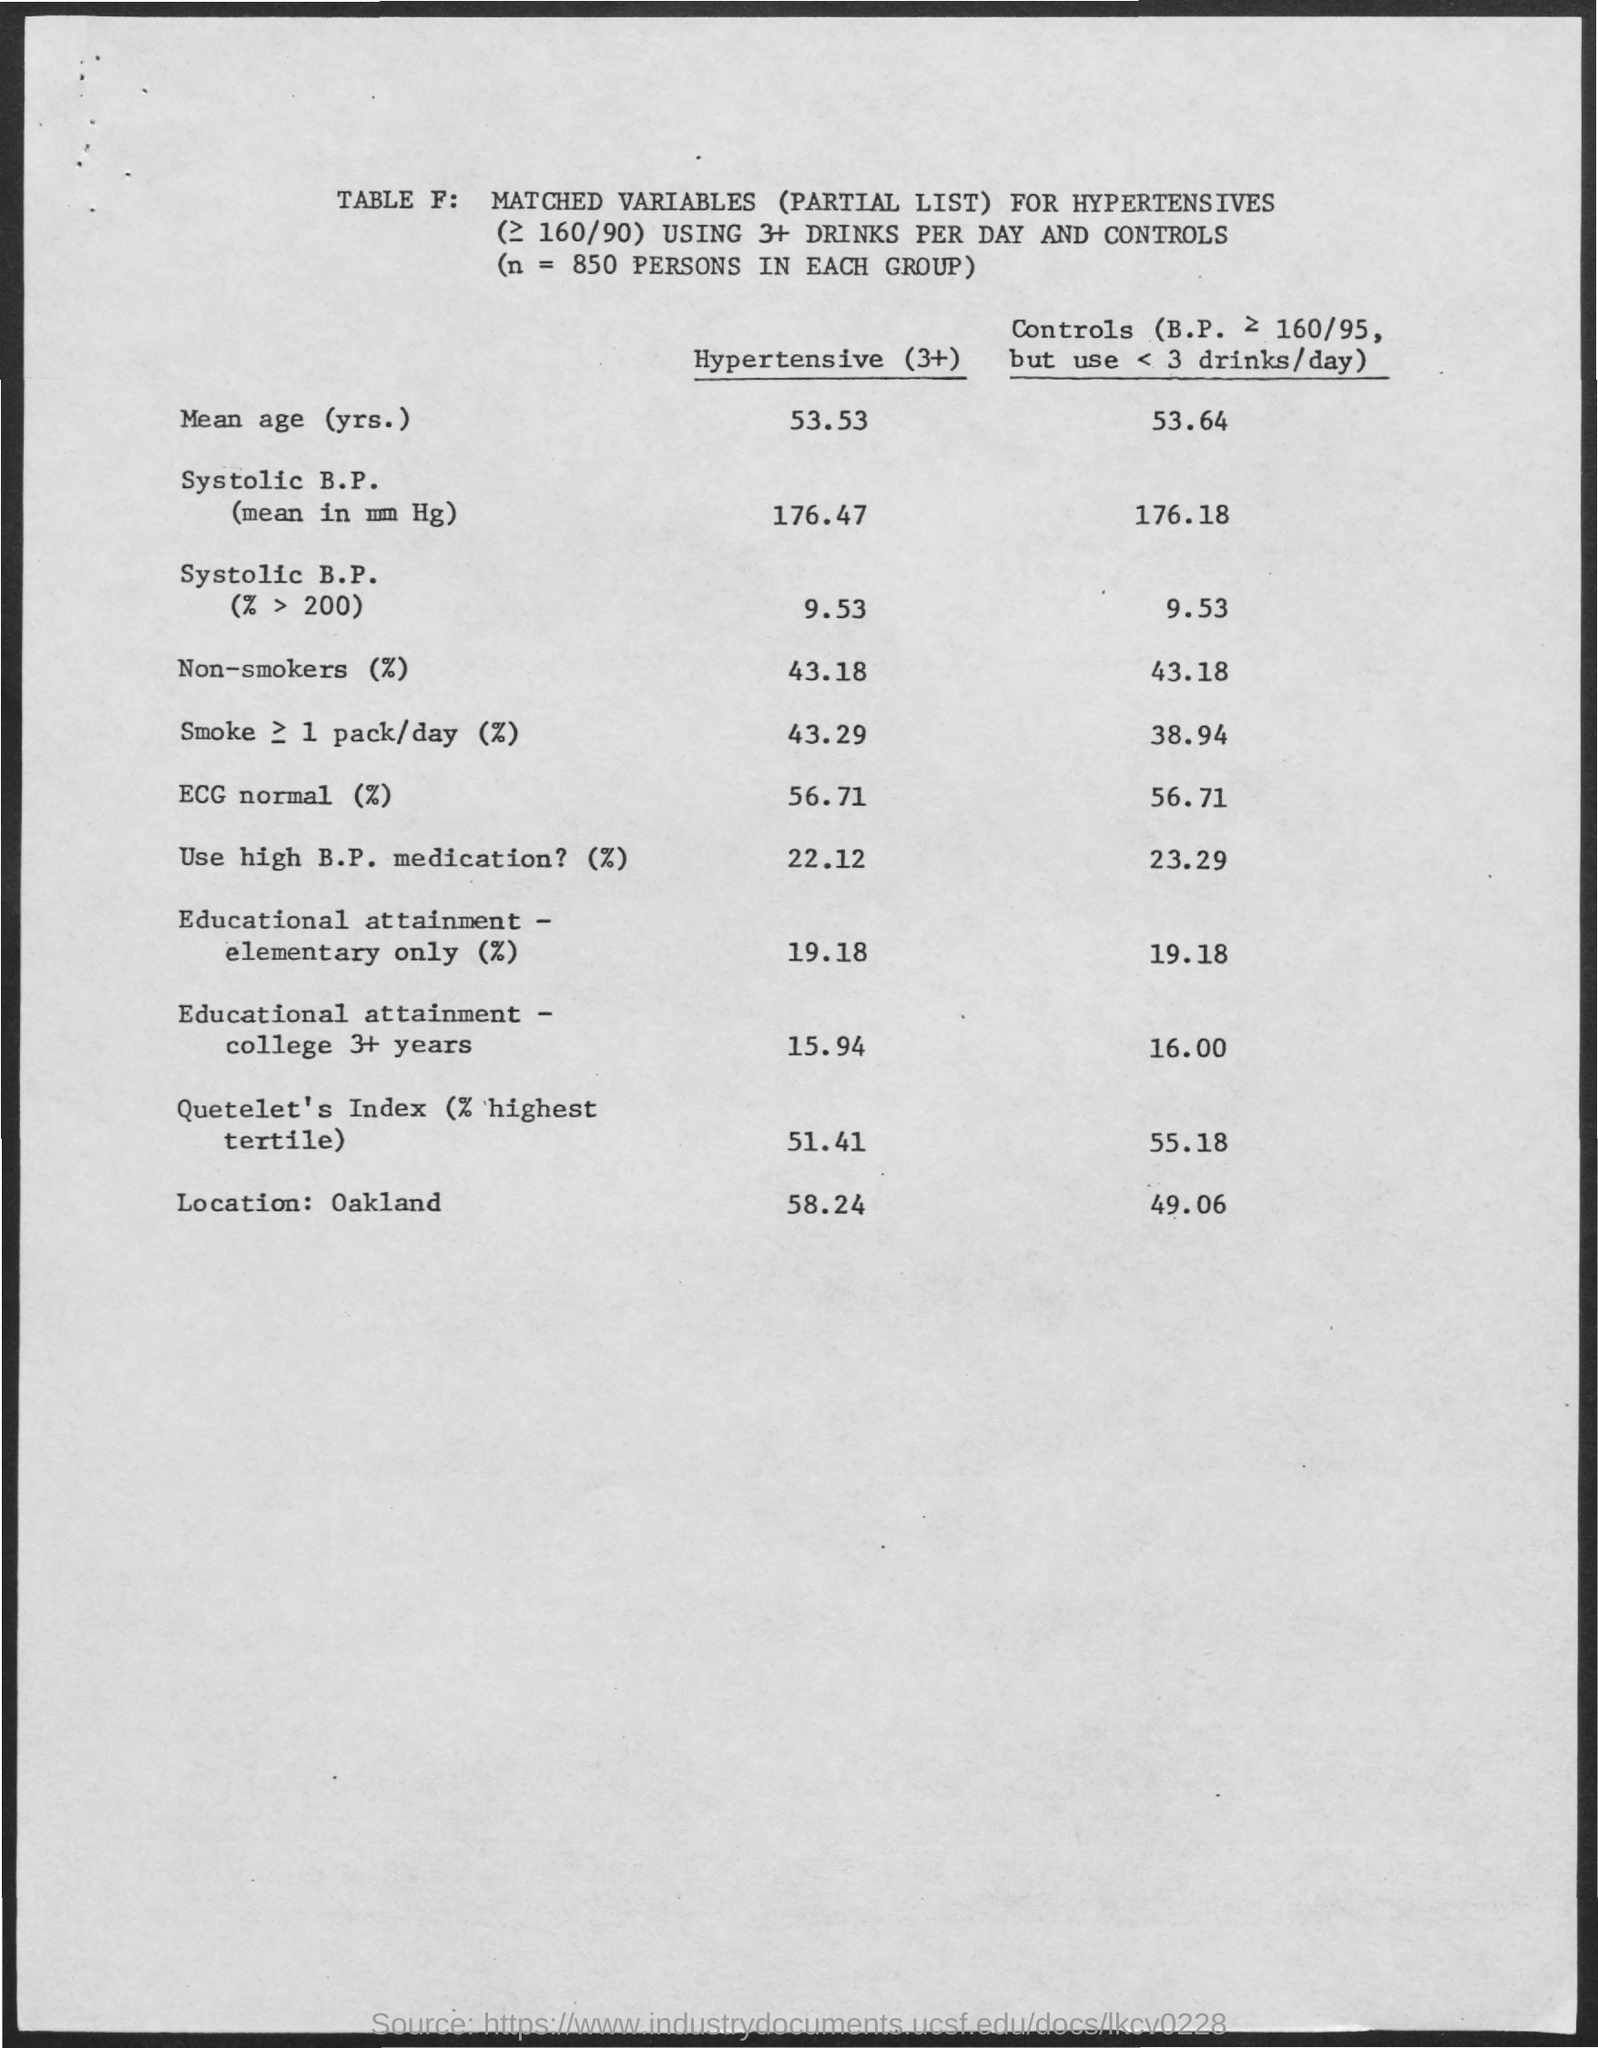Specify some key components in this picture. Systolic blood pressure is the pressure in the arteries when the heart beats, and it is measured in millimeters of mercury (mm Hg). N is equal to 850 persons in each group. 